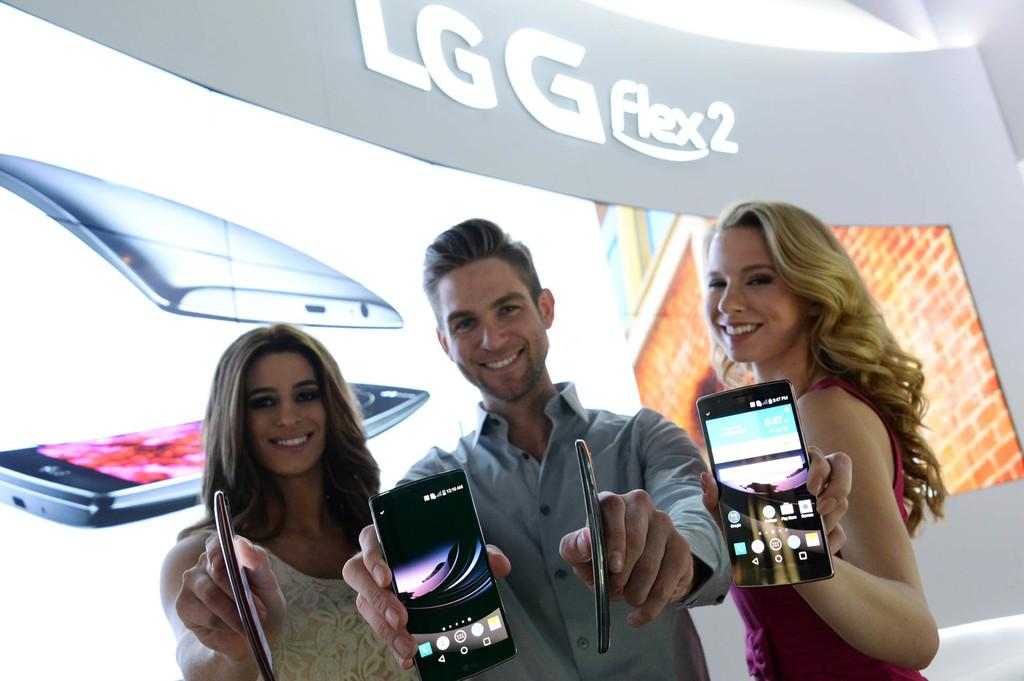How many people are in the image? There are three people in the image. What are the people doing in the image? The people are promoting a mobile phone. Which company's mobile phone are they promoting? The mobile phone is from the LG company. Can you describe the background of the image? There is an LG logo and a video of the mobile phone in the background of the image. How much salt is being used to season the mobile phone in the image? There is no salt present in the image, as it features people promoting a mobile phone from the LG company. 